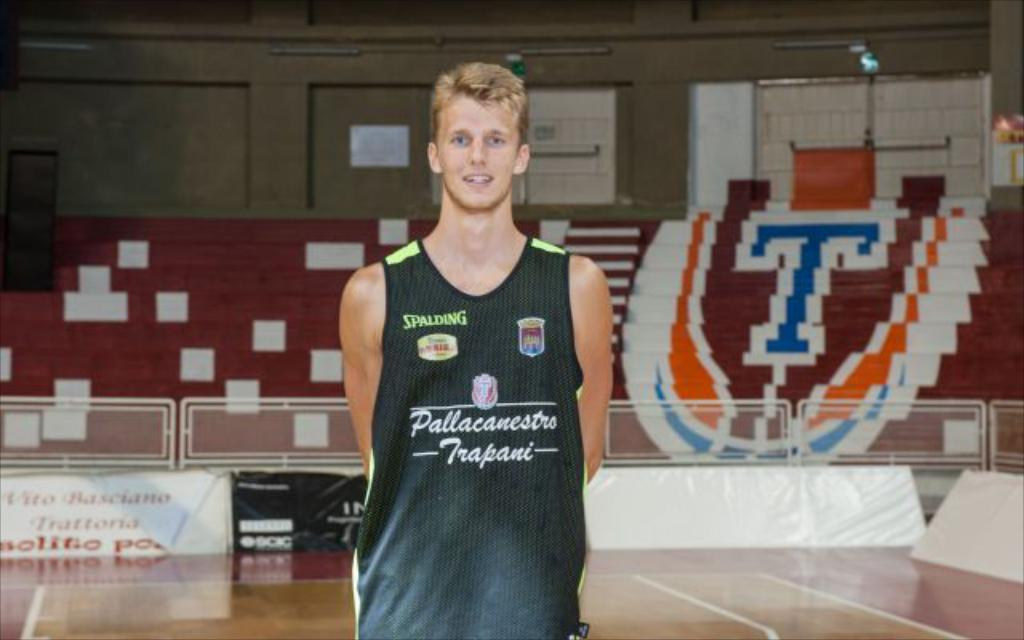Provide a one-sentence caption for the provided image. White basketball player for team Pallacanestro poses for the camera. 